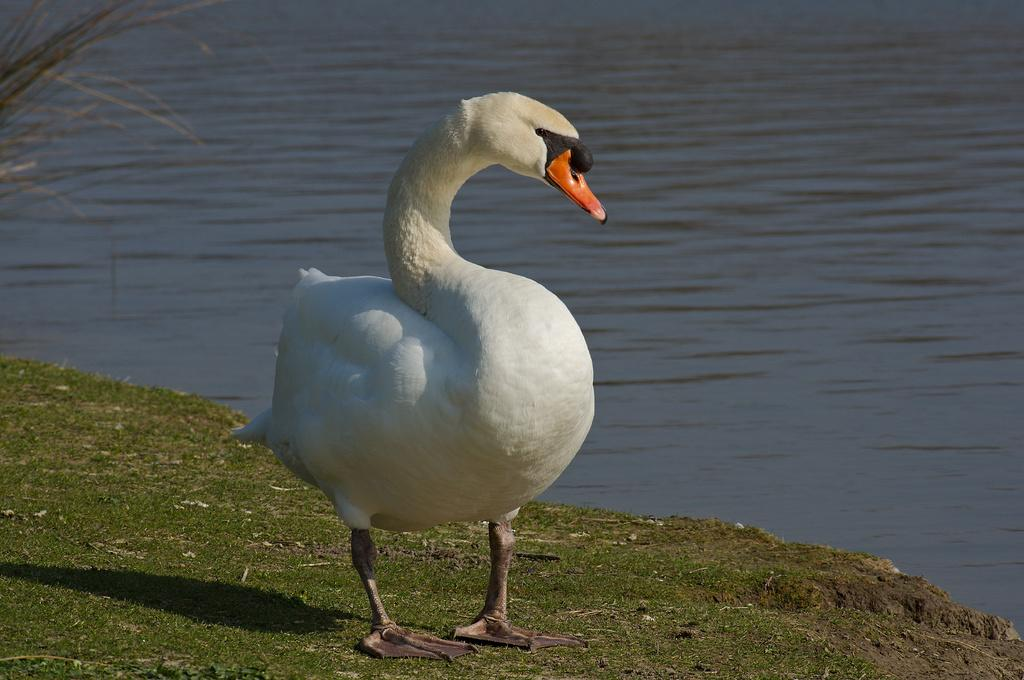What animal is on the grass in the image? There is a swan on the grass in the image. What can be seen in the background of the image? Water is visible in the background of the image. What type of footwear is the swan wearing in the image? Swans do not wear footwear, and there is no footwear visible in the image. 